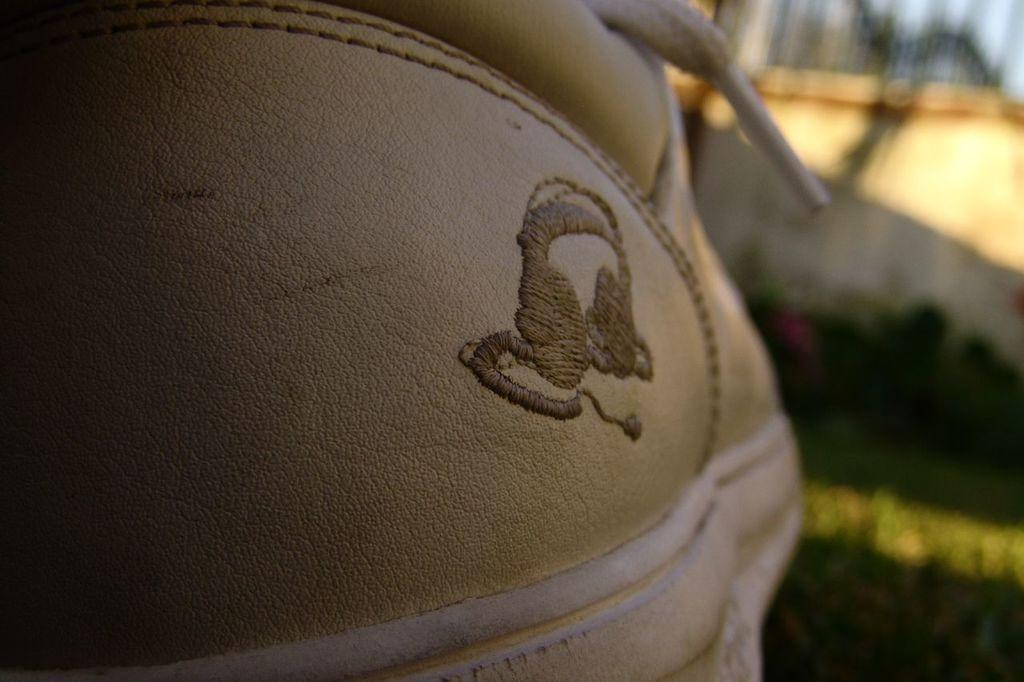What is the color and location of the object on the left side of the image? The object on the left side of the image is brown. What is the color and location of the element on the right side of the image? The element on the right side of the image is black. What structures can be seen on the right side of the image? There is a building visible on the right side of the image. What type of vegetation is present on the right side of the image? There are trees present on the right side of the image. What is visible at the top of the image? The sky is visible at the top of the image. Can you tell me how the spy is using the cloth in the image? There is no spy or cloth present in the image. What type of show is being performed by the trees on the right side of the image? There is no show being performed by the trees in the image; they are simply standing. 